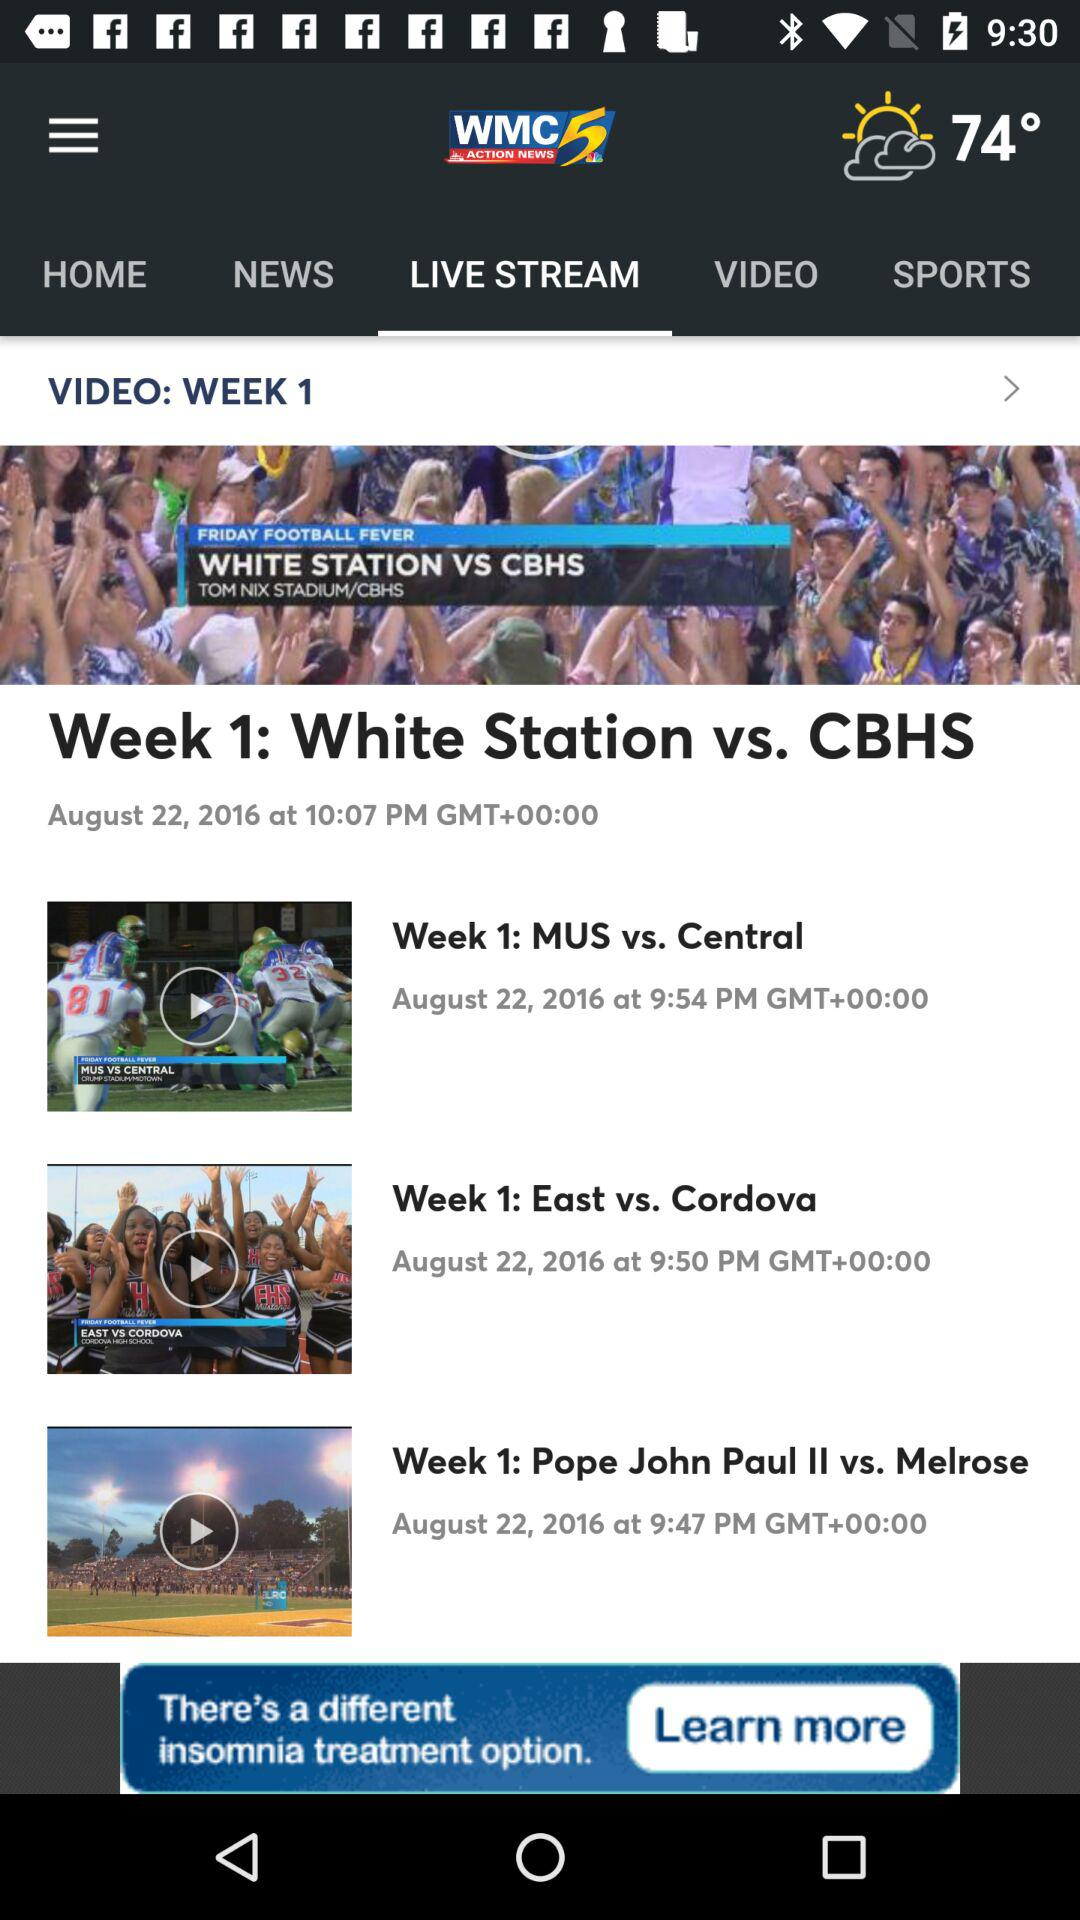Who wrote the "Week 1: White Station vs. CBHS" article?
When the provided information is insufficient, respond with <no answer>. <no answer> 